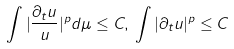Convert formula to latex. <formula><loc_0><loc_0><loc_500><loc_500>\int | \frac { \partial _ { t } u } { u } | ^ { p } d \mu \leq C , \, \int | \partial _ { t } u | ^ { p } \leq C</formula> 